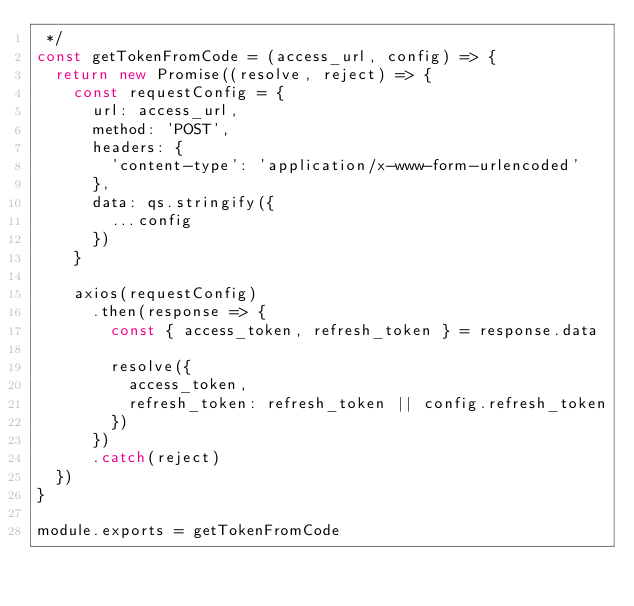Convert code to text. <code><loc_0><loc_0><loc_500><loc_500><_JavaScript_> */
const getTokenFromCode = (access_url, config) => {
  return new Promise((resolve, reject) => {
    const requestConfig = {
      url: access_url,
      method: 'POST',
      headers: {
        'content-type': 'application/x-www-form-urlencoded'
      },
      data: qs.stringify({
        ...config
      })
    }

    axios(requestConfig)
      .then(response => {
        const { access_token, refresh_token } = response.data

        resolve({
          access_token,
          refresh_token: refresh_token || config.refresh_token
        })
      })
      .catch(reject)
  })
}

module.exports = getTokenFromCode
</code> 